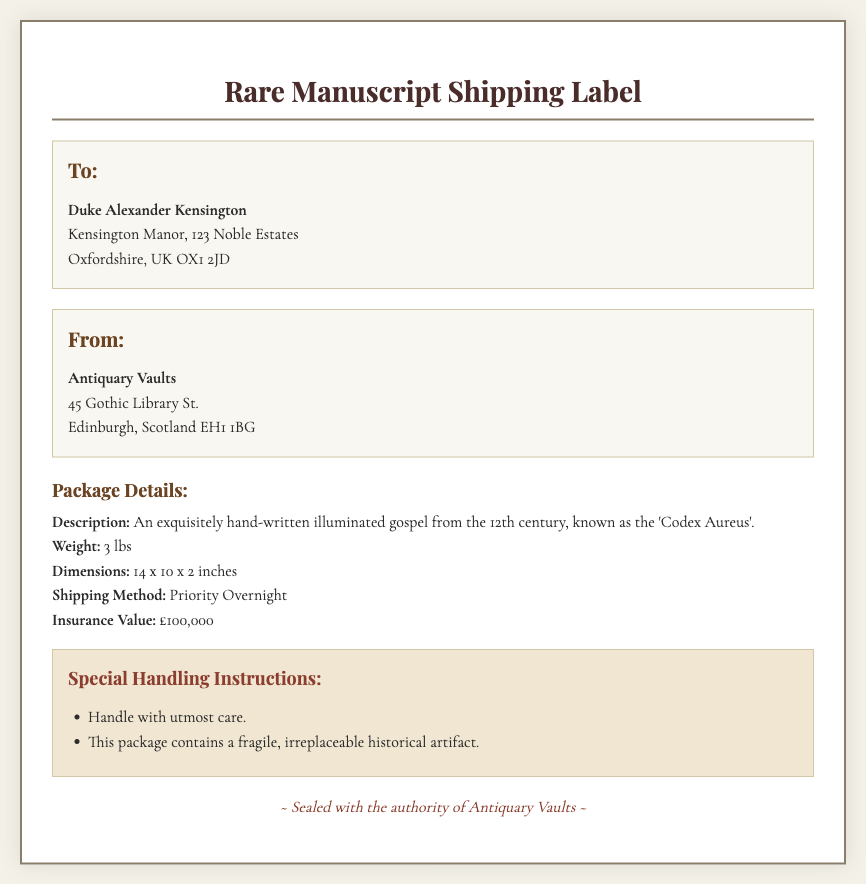What is the title of the manuscript? The title of the manuscript, as stated, is 'Codex Aureus'.
Answer: Codex Aureus What is the weight of the package? The weight is specified in the document as 3 lbs.
Answer: 3 lbs Who is the recipient? The recipient's name is provided in the address section of the document.
Answer: Duke Alexander Kensington What is the insurance value of the manuscript? The document lists the insurance value of the manuscript as £100,000.
Answer: £100,000 What is the shipping method for the package? The shipping method mentioned in the document is Priority Overnight.
Answer: Priority Overnight Why should the package be handled with care? The document specifies that the package contains a fragile, irreplaceable historical artifact.
Answer: Fragile, irreplaceable historical artifact What is the dimension of the package? The dimensions of the package are stated in the document as 14 x 10 x 2 inches.
Answer: 14 x 10 x 2 inches Where is the sender located? The sender's location is detailed in the 'From' section: 45 Gothic Library St., Edinburgh, Scotland EH1 1BG.
Answer: 45 Gothic Library St., Edinburgh, Scotland EH1 1BG What type of document is this? The document is identified as a shipping label for a rare manuscript.
Answer: Shipping label for a rare manuscript 